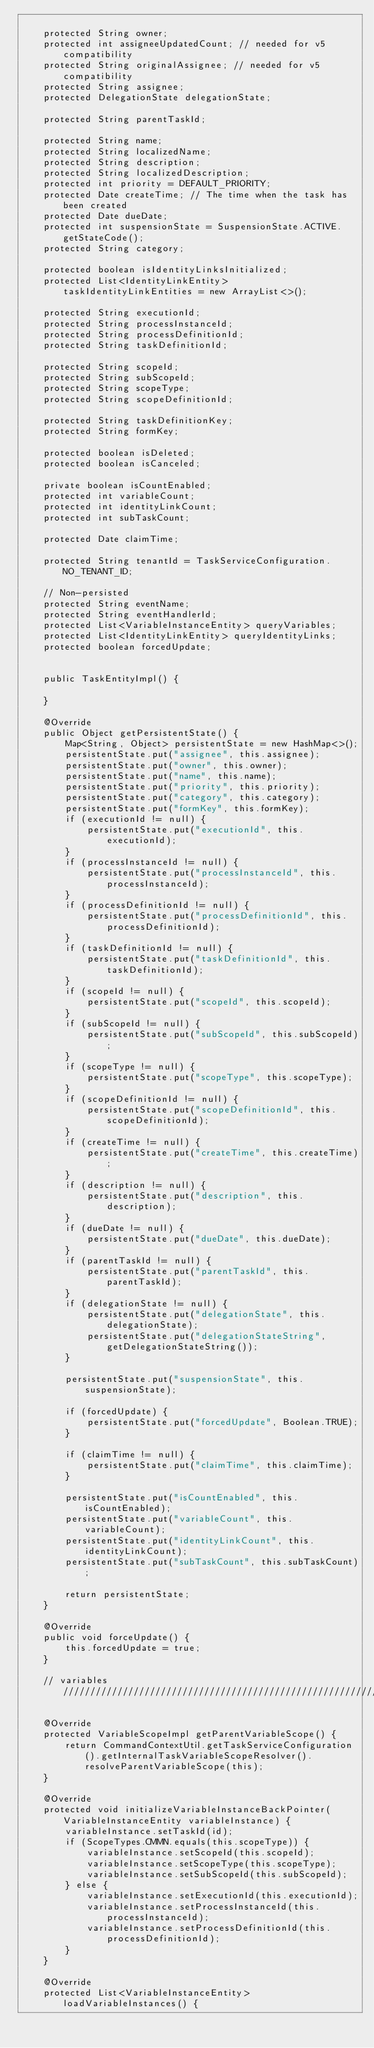Convert code to text. <code><loc_0><loc_0><loc_500><loc_500><_Java_>
    protected String owner;
    protected int assigneeUpdatedCount; // needed for v5 compatibility
    protected String originalAssignee; // needed for v5 compatibility
    protected String assignee;
    protected DelegationState delegationState;

    protected String parentTaskId;

    protected String name;
    protected String localizedName;
    protected String description;
    protected String localizedDescription;
    protected int priority = DEFAULT_PRIORITY;
    protected Date createTime; // The time when the task has been created
    protected Date dueDate;
    protected int suspensionState = SuspensionState.ACTIVE.getStateCode();
    protected String category;

    protected boolean isIdentityLinksInitialized;
    protected List<IdentityLinkEntity> taskIdentityLinkEntities = new ArrayList<>();

    protected String executionId;
    protected String processInstanceId;
    protected String processDefinitionId;
    protected String taskDefinitionId;
    
    protected String scopeId;
    protected String subScopeId;
    protected String scopeType;
    protected String scopeDefinitionId;

    protected String taskDefinitionKey;
    protected String formKey;

    protected boolean isDeleted;
    protected boolean isCanceled;

    private boolean isCountEnabled;
    protected int variableCount;
    protected int identityLinkCount;
    protected int subTaskCount;

    protected Date claimTime;

    protected String tenantId = TaskServiceConfiguration.NO_TENANT_ID;

    // Non-persisted
    protected String eventName;
    protected String eventHandlerId;
    protected List<VariableInstanceEntity> queryVariables;
    protected List<IdentityLinkEntity> queryIdentityLinks;
    protected boolean forcedUpdate;


    public TaskEntityImpl() {

    }

    @Override
    public Object getPersistentState() {
        Map<String, Object> persistentState = new HashMap<>();
        persistentState.put("assignee", this.assignee);
        persistentState.put("owner", this.owner);
        persistentState.put("name", this.name);
        persistentState.put("priority", this.priority);
        persistentState.put("category", this.category);
        persistentState.put("formKey", this.formKey);
        if (executionId != null) {
            persistentState.put("executionId", this.executionId);
        }
        if (processInstanceId != null) {
            persistentState.put("processInstanceId", this.processInstanceId);
        }
        if (processDefinitionId != null) {
            persistentState.put("processDefinitionId", this.processDefinitionId);
        }
        if (taskDefinitionId != null) {
            persistentState.put("taskDefinitionId", this.taskDefinitionId);
        }
        if (scopeId != null) {
            persistentState.put("scopeId", this.scopeId);
        }
        if (subScopeId != null) {
            persistentState.put("subScopeId", this.subScopeId);
        }
        if (scopeType != null) {
            persistentState.put("scopeType", this.scopeType);
        }
        if (scopeDefinitionId != null) {
            persistentState.put("scopeDefinitionId", this.scopeDefinitionId);
        }
        if (createTime != null) {
            persistentState.put("createTime", this.createTime);
        }
        if (description != null) {
            persistentState.put("description", this.description);
        }
        if (dueDate != null) {
            persistentState.put("dueDate", this.dueDate);
        }
        if (parentTaskId != null) {
            persistentState.put("parentTaskId", this.parentTaskId);
        }
        if (delegationState != null) {
            persistentState.put("delegationState", this.delegationState);
            persistentState.put("delegationStateString", getDelegationStateString());
        }

        persistentState.put("suspensionState", this.suspensionState);

        if (forcedUpdate) {
            persistentState.put("forcedUpdate", Boolean.TRUE);
        }

        if (claimTime != null) {
            persistentState.put("claimTime", this.claimTime);
        }

        persistentState.put("isCountEnabled", this.isCountEnabled);
        persistentState.put("variableCount", this.variableCount);
        persistentState.put("identityLinkCount", this.identityLinkCount);
        persistentState.put("subTaskCount", this.subTaskCount);

        return persistentState;
    }

    @Override
    public void forceUpdate() {
        this.forcedUpdate = true;
    }

    // variables //////////////////////////////////////////////////////////////////

    @Override
    protected VariableScopeImpl getParentVariableScope() {
        return CommandContextUtil.getTaskServiceConfiguration().getInternalTaskVariableScopeResolver().resolveParentVariableScope(this);
    }

    @Override
    protected void initializeVariableInstanceBackPointer(VariableInstanceEntity variableInstance) {
        variableInstance.setTaskId(id);
        if (ScopeTypes.CMMN.equals(this.scopeType)) {
            variableInstance.setScopeId(this.scopeId);
            variableInstance.setScopeType(this.scopeType);
            variableInstance.setSubScopeId(this.subScopeId);
        } else {
            variableInstance.setExecutionId(this.executionId);
            variableInstance.setProcessInstanceId(this.processInstanceId);
            variableInstance.setProcessDefinitionId(this.processDefinitionId);
        }
    }

    @Override
    protected List<VariableInstanceEntity> loadVariableInstances() {</code> 